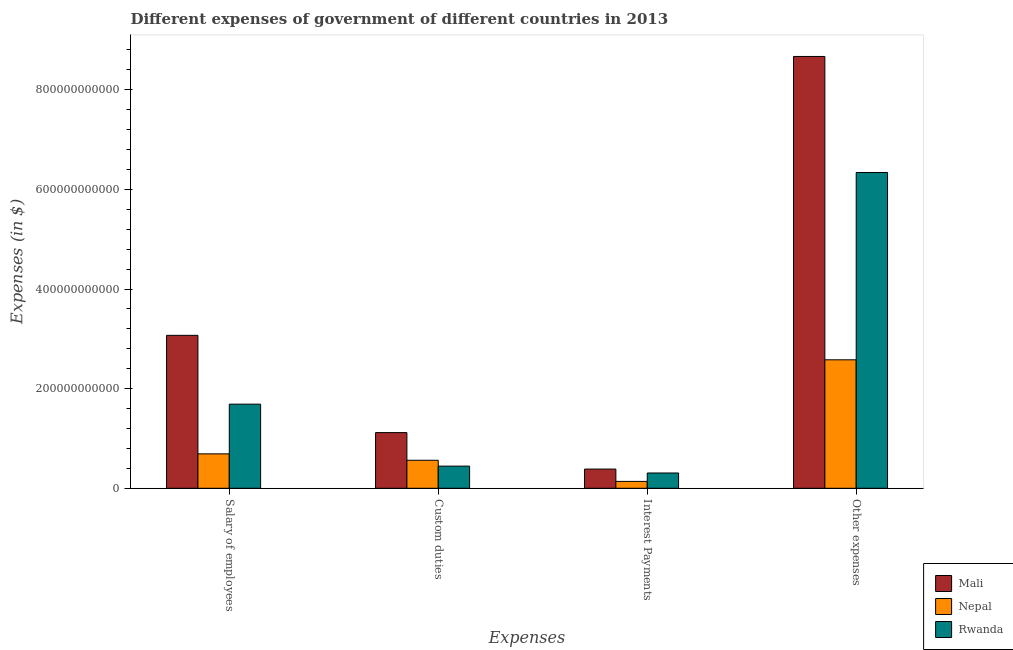How many different coloured bars are there?
Make the answer very short. 3. How many groups of bars are there?
Give a very brief answer. 4. Are the number of bars per tick equal to the number of legend labels?
Ensure brevity in your answer.  Yes. What is the label of the 4th group of bars from the left?
Provide a succinct answer. Other expenses. What is the amount spent on other expenses in Rwanda?
Give a very brief answer. 6.34e+11. Across all countries, what is the maximum amount spent on interest payments?
Your response must be concise. 3.86e+1. Across all countries, what is the minimum amount spent on other expenses?
Offer a terse response. 2.58e+11. In which country was the amount spent on interest payments maximum?
Offer a terse response. Mali. In which country was the amount spent on other expenses minimum?
Ensure brevity in your answer.  Nepal. What is the total amount spent on custom duties in the graph?
Give a very brief answer. 2.13e+11. What is the difference between the amount spent on interest payments in Mali and that in Nepal?
Provide a succinct answer. 2.47e+1. What is the difference between the amount spent on salary of employees in Rwanda and the amount spent on interest payments in Nepal?
Make the answer very short. 1.55e+11. What is the average amount spent on salary of employees per country?
Give a very brief answer. 1.82e+11. What is the difference between the amount spent on interest payments and amount spent on other expenses in Nepal?
Offer a terse response. -2.44e+11. What is the ratio of the amount spent on other expenses in Mali to that in Nepal?
Your answer should be compact. 3.36. What is the difference between the highest and the second highest amount spent on interest payments?
Make the answer very short. 7.86e+09. What is the difference between the highest and the lowest amount spent on interest payments?
Provide a short and direct response. 2.47e+1. In how many countries, is the amount spent on custom duties greater than the average amount spent on custom duties taken over all countries?
Offer a very short reply. 1. Is the sum of the amount spent on interest payments in Nepal and Mali greater than the maximum amount spent on salary of employees across all countries?
Your answer should be very brief. No. What does the 2nd bar from the left in Custom duties represents?
Provide a succinct answer. Nepal. What does the 3rd bar from the right in Other expenses represents?
Keep it short and to the point. Mali. Is it the case that in every country, the sum of the amount spent on salary of employees and amount spent on custom duties is greater than the amount spent on interest payments?
Make the answer very short. Yes. What is the difference between two consecutive major ticks on the Y-axis?
Offer a terse response. 2.00e+11. Are the values on the major ticks of Y-axis written in scientific E-notation?
Your answer should be compact. No. Does the graph contain any zero values?
Your response must be concise. No. Does the graph contain grids?
Your response must be concise. No. Where does the legend appear in the graph?
Keep it short and to the point. Bottom right. What is the title of the graph?
Your answer should be very brief. Different expenses of government of different countries in 2013. Does "Small states" appear as one of the legend labels in the graph?
Offer a terse response. No. What is the label or title of the X-axis?
Your answer should be very brief. Expenses. What is the label or title of the Y-axis?
Make the answer very short. Expenses (in $). What is the Expenses (in $) of Mali in Salary of employees?
Make the answer very short. 3.07e+11. What is the Expenses (in $) in Nepal in Salary of employees?
Keep it short and to the point. 6.91e+1. What is the Expenses (in $) in Rwanda in Salary of employees?
Your response must be concise. 1.69e+11. What is the Expenses (in $) in Mali in Custom duties?
Give a very brief answer. 1.12e+11. What is the Expenses (in $) in Nepal in Custom duties?
Keep it short and to the point. 5.62e+1. What is the Expenses (in $) of Rwanda in Custom duties?
Give a very brief answer. 4.45e+1. What is the Expenses (in $) of Mali in Interest Payments?
Offer a terse response. 3.86e+1. What is the Expenses (in $) of Nepal in Interest Payments?
Offer a very short reply. 1.38e+1. What is the Expenses (in $) of Rwanda in Interest Payments?
Provide a succinct answer. 3.07e+1. What is the Expenses (in $) in Mali in Other expenses?
Your answer should be very brief. 8.67e+11. What is the Expenses (in $) in Nepal in Other expenses?
Provide a short and direct response. 2.58e+11. What is the Expenses (in $) of Rwanda in Other expenses?
Your answer should be very brief. 6.34e+11. Across all Expenses, what is the maximum Expenses (in $) of Mali?
Offer a very short reply. 8.67e+11. Across all Expenses, what is the maximum Expenses (in $) in Nepal?
Keep it short and to the point. 2.58e+11. Across all Expenses, what is the maximum Expenses (in $) in Rwanda?
Provide a short and direct response. 6.34e+11. Across all Expenses, what is the minimum Expenses (in $) of Mali?
Keep it short and to the point. 3.86e+1. Across all Expenses, what is the minimum Expenses (in $) in Nepal?
Your answer should be compact. 1.38e+1. Across all Expenses, what is the minimum Expenses (in $) in Rwanda?
Offer a terse response. 3.07e+1. What is the total Expenses (in $) of Mali in the graph?
Give a very brief answer. 1.32e+12. What is the total Expenses (in $) in Nepal in the graph?
Make the answer very short. 3.97e+11. What is the total Expenses (in $) in Rwanda in the graph?
Offer a very short reply. 8.78e+11. What is the difference between the Expenses (in $) of Mali in Salary of employees and that in Custom duties?
Provide a short and direct response. 1.95e+11. What is the difference between the Expenses (in $) of Nepal in Salary of employees and that in Custom duties?
Your answer should be very brief. 1.29e+1. What is the difference between the Expenses (in $) of Rwanda in Salary of employees and that in Custom duties?
Ensure brevity in your answer.  1.24e+11. What is the difference between the Expenses (in $) of Mali in Salary of employees and that in Interest Payments?
Provide a succinct answer. 2.68e+11. What is the difference between the Expenses (in $) of Nepal in Salary of employees and that in Interest Payments?
Offer a very short reply. 5.53e+1. What is the difference between the Expenses (in $) in Rwanda in Salary of employees and that in Interest Payments?
Provide a short and direct response. 1.38e+11. What is the difference between the Expenses (in $) of Mali in Salary of employees and that in Other expenses?
Offer a terse response. -5.60e+11. What is the difference between the Expenses (in $) of Nepal in Salary of employees and that in Other expenses?
Your response must be concise. -1.89e+11. What is the difference between the Expenses (in $) of Rwanda in Salary of employees and that in Other expenses?
Make the answer very short. -4.65e+11. What is the difference between the Expenses (in $) of Mali in Custom duties and that in Interest Payments?
Give a very brief answer. 7.32e+1. What is the difference between the Expenses (in $) in Nepal in Custom duties and that in Interest Payments?
Keep it short and to the point. 4.24e+1. What is the difference between the Expenses (in $) of Rwanda in Custom duties and that in Interest Payments?
Your answer should be compact. 1.38e+1. What is the difference between the Expenses (in $) of Mali in Custom duties and that in Other expenses?
Your answer should be compact. -7.55e+11. What is the difference between the Expenses (in $) of Nepal in Custom duties and that in Other expenses?
Your answer should be compact. -2.02e+11. What is the difference between the Expenses (in $) in Rwanda in Custom duties and that in Other expenses?
Your response must be concise. -5.89e+11. What is the difference between the Expenses (in $) in Mali in Interest Payments and that in Other expenses?
Your answer should be compact. -8.28e+11. What is the difference between the Expenses (in $) of Nepal in Interest Payments and that in Other expenses?
Provide a short and direct response. -2.44e+11. What is the difference between the Expenses (in $) in Rwanda in Interest Payments and that in Other expenses?
Offer a terse response. -6.03e+11. What is the difference between the Expenses (in $) of Mali in Salary of employees and the Expenses (in $) of Nepal in Custom duties?
Your answer should be compact. 2.51e+11. What is the difference between the Expenses (in $) in Mali in Salary of employees and the Expenses (in $) in Rwanda in Custom duties?
Give a very brief answer. 2.63e+11. What is the difference between the Expenses (in $) of Nepal in Salary of employees and the Expenses (in $) of Rwanda in Custom duties?
Your answer should be very brief. 2.46e+1. What is the difference between the Expenses (in $) of Mali in Salary of employees and the Expenses (in $) of Nepal in Interest Payments?
Offer a terse response. 2.93e+11. What is the difference between the Expenses (in $) in Mali in Salary of employees and the Expenses (in $) in Rwanda in Interest Payments?
Make the answer very short. 2.76e+11. What is the difference between the Expenses (in $) of Nepal in Salary of employees and the Expenses (in $) of Rwanda in Interest Payments?
Provide a short and direct response. 3.84e+1. What is the difference between the Expenses (in $) in Mali in Salary of employees and the Expenses (in $) in Nepal in Other expenses?
Keep it short and to the point. 4.91e+1. What is the difference between the Expenses (in $) in Mali in Salary of employees and the Expenses (in $) in Rwanda in Other expenses?
Your answer should be compact. -3.27e+11. What is the difference between the Expenses (in $) in Nepal in Salary of employees and the Expenses (in $) in Rwanda in Other expenses?
Provide a short and direct response. -5.65e+11. What is the difference between the Expenses (in $) in Mali in Custom duties and the Expenses (in $) in Nepal in Interest Payments?
Keep it short and to the point. 9.80e+1. What is the difference between the Expenses (in $) in Mali in Custom duties and the Expenses (in $) in Rwanda in Interest Payments?
Make the answer very short. 8.11e+1. What is the difference between the Expenses (in $) of Nepal in Custom duties and the Expenses (in $) of Rwanda in Interest Payments?
Your answer should be compact. 2.55e+1. What is the difference between the Expenses (in $) in Mali in Custom duties and the Expenses (in $) in Nepal in Other expenses?
Make the answer very short. -1.46e+11. What is the difference between the Expenses (in $) of Mali in Custom duties and the Expenses (in $) of Rwanda in Other expenses?
Your response must be concise. -5.22e+11. What is the difference between the Expenses (in $) in Nepal in Custom duties and the Expenses (in $) in Rwanda in Other expenses?
Offer a terse response. -5.78e+11. What is the difference between the Expenses (in $) in Mali in Interest Payments and the Expenses (in $) in Nepal in Other expenses?
Your response must be concise. -2.19e+11. What is the difference between the Expenses (in $) of Mali in Interest Payments and the Expenses (in $) of Rwanda in Other expenses?
Provide a short and direct response. -5.95e+11. What is the difference between the Expenses (in $) in Nepal in Interest Payments and the Expenses (in $) in Rwanda in Other expenses?
Offer a very short reply. -6.20e+11. What is the average Expenses (in $) of Mali per Expenses?
Make the answer very short. 3.31e+11. What is the average Expenses (in $) of Nepal per Expenses?
Give a very brief answer. 9.93e+1. What is the average Expenses (in $) of Rwanda per Expenses?
Make the answer very short. 2.20e+11. What is the difference between the Expenses (in $) of Mali and Expenses (in $) of Nepal in Salary of employees?
Give a very brief answer. 2.38e+11. What is the difference between the Expenses (in $) in Mali and Expenses (in $) in Rwanda in Salary of employees?
Keep it short and to the point. 1.38e+11. What is the difference between the Expenses (in $) of Nepal and Expenses (in $) of Rwanda in Salary of employees?
Your answer should be very brief. -9.98e+1. What is the difference between the Expenses (in $) of Mali and Expenses (in $) of Nepal in Custom duties?
Keep it short and to the point. 5.55e+1. What is the difference between the Expenses (in $) in Mali and Expenses (in $) in Rwanda in Custom duties?
Provide a short and direct response. 6.73e+1. What is the difference between the Expenses (in $) of Nepal and Expenses (in $) of Rwanda in Custom duties?
Your answer should be compact. 1.17e+1. What is the difference between the Expenses (in $) of Mali and Expenses (in $) of Nepal in Interest Payments?
Offer a terse response. 2.47e+1. What is the difference between the Expenses (in $) of Mali and Expenses (in $) of Rwanda in Interest Payments?
Provide a short and direct response. 7.86e+09. What is the difference between the Expenses (in $) in Nepal and Expenses (in $) in Rwanda in Interest Payments?
Your answer should be very brief. -1.69e+1. What is the difference between the Expenses (in $) in Mali and Expenses (in $) in Nepal in Other expenses?
Provide a short and direct response. 6.09e+11. What is the difference between the Expenses (in $) of Mali and Expenses (in $) of Rwanda in Other expenses?
Your answer should be compact. 2.33e+11. What is the difference between the Expenses (in $) in Nepal and Expenses (in $) in Rwanda in Other expenses?
Give a very brief answer. -3.76e+11. What is the ratio of the Expenses (in $) in Mali in Salary of employees to that in Custom duties?
Your answer should be very brief. 2.75. What is the ratio of the Expenses (in $) of Nepal in Salary of employees to that in Custom duties?
Your answer should be compact. 1.23. What is the ratio of the Expenses (in $) in Rwanda in Salary of employees to that in Custom duties?
Provide a short and direct response. 3.8. What is the ratio of the Expenses (in $) of Mali in Salary of employees to that in Interest Payments?
Offer a terse response. 7.96. What is the ratio of the Expenses (in $) of Nepal in Salary of employees to that in Interest Payments?
Offer a very short reply. 5.01. What is the ratio of the Expenses (in $) of Rwanda in Salary of employees to that in Interest Payments?
Make the answer very short. 5.5. What is the ratio of the Expenses (in $) of Mali in Salary of employees to that in Other expenses?
Provide a short and direct response. 0.35. What is the ratio of the Expenses (in $) of Nepal in Salary of employees to that in Other expenses?
Offer a terse response. 0.27. What is the ratio of the Expenses (in $) in Rwanda in Salary of employees to that in Other expenses?
Ensure brevity in your answer.  0.27. What is the ratio of the Expenses (in $) of Mali in Custom duties to that in Interest Payments?
Your answer should be compact. 2.9. What is the ratio of the Expenses (in $) of Nepal in Custom duties to that in Interest Payments?
Offer a terse response. 4.07. What is the ratio of the Expenses (in $) in Rwanda in Custom duties to that in Interest Payments?
Give a very brief answer. 1.45. What is the ratio of the Expenses (in $) in Mali in Custom duties to that in Other expenses?
Make the answer very short. 0.13. What is the ratio of the Expenses (in $) of Nepal in Custom duties to that in Other expenses?
Make the answer very short. 0.22. What is the ratio of the Expenses (in $) of Rwanda in Custom duties to that in Other expenses?
Your answer should be very brief. 0.07. What is the ratio of the Expenses (in $) in Mali in Interest Payments to that in Other expenses?
Give a very brief answer. 0.04. What is the ratio of the Expenses (in $) of Nepal in Interest Payments to that in Other expenses?
Keep it short and to the point. 0.05. What is the ratio of the Expenses (in $) in Rwanda in Interest Payments to that in Other expenses?
Your response must be concise. 0.05. What is the difference between the highest and the second highest Expenses (in $) in Mali?
Ensure brevity in your answer.  5.60e+11. What is the difference between the highest and the second highest Expenses (in $) in Nepal?
Keep it short and to the point. 1.89e+11. What is the difference between the highest and the second highest Expenses (in $) of Rwanda?
Your answer should be compact. 4.65e+11. What is the difference between the highest and the lowest Expenses (in $) in Mali?
Make the answer very short. 8.28e+11. What is the difference between the highest and the lowest Expenses (in $) in Nepal?
Your response must be concise. 2.44e+11. What is the difference between the highest and the lowest Expenses (in $) of Rwanda?
Provide a short and direct response. 6.03e+11. 